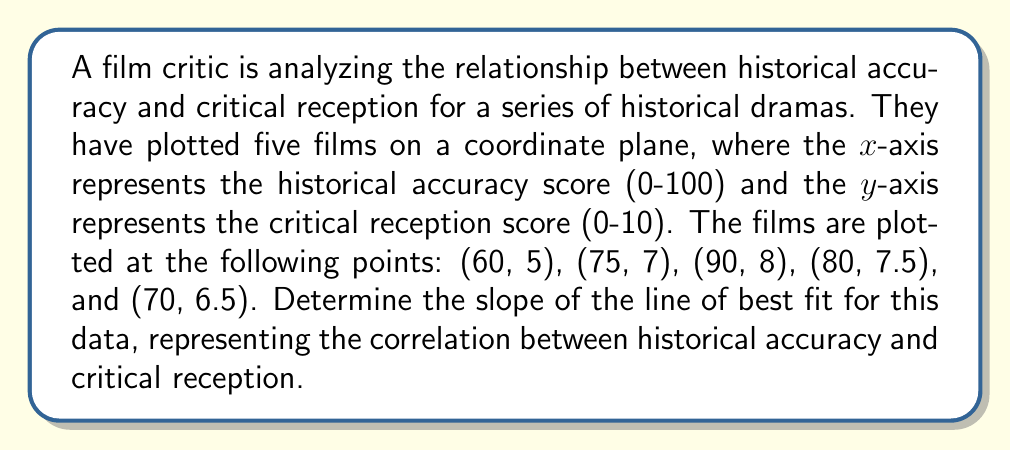Teach me how to tackle this problem. To find the slope of the line of best fit, we'll use the least squares method:

1. Calculate the means of x and y:
   $\bar{x} = \frac{60 + 75 + 90 + 80 + 70}{5} = 75$
   $\bar{y} = \frac{5 + 7 + 8 + 7.5 + 6.5}{5} = 6.8$

2. Calculate $\sum(x - \bar{x})(y - \bar{y})$:
   $(60 - 75)(5 - 6.8) + (75 - 75)(7 - 6.8) + (90 - 75)(8 - 6.8) + (80 - 75)(7.5 - 6.8) + (70 - 75)(6.5 - 6.8)$
   $= (-15)(-1.8) + (0)(0.2) + (15)(1.2) + (5)(0.7) + (-5)(-0.3)$
   $= 27 + 0 + 18 + 3.5 + 1.5 = 50$

3. Calculate $\sum(x - \bar{x})^2$:
   $(-15)^2 + (0)^2 + (15)^2 + (5)^2 + (-5)^2$
   $= 225 + 0 + 225 + 25 + 25 = 500$

4. The slope (m) of the line of best fit is given by:
   $$m = \frac{\sum(x - \bar{x})(y - \bar{y})}{\sum(x - \bar{x})^2} = \frac{50}{500} = 0.1$$

Thus, the slope of the line representing the correlation between historical accuracy and critical reception is 0.1.
Answer: 0.1 